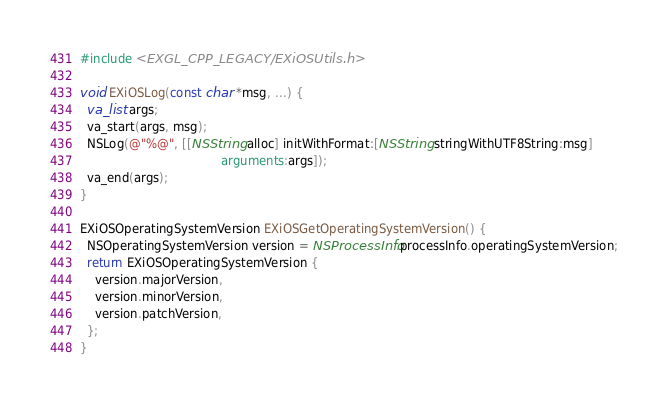Convert code to text. <code><loc_0><loc_0><loc_500><loc_500><_ObjectiveC_>#include <EXGL_CPP_LEGACY/EXiOSUtils.h>

void EXiOSLog(const char *msg, ...) {
  va_list args;
  va_start(args, msg);
  NSLog(@"%@", [[NSString alloc] initWithFormat:[NSString stringWithUTF8String:msg]
                                      arguments:args]);
  va_end(args);
}

EXiOSOperatingSystemVersion EXiOSGetOperatingSystemVersion() {
  NSOperatingSystemVersion version = NSProcessInfo.processInfo.operatingSystemVersion;
  return EXiOSOperatingSystemVersion {
    version.majorVersion,
    version.minorVersion,
    version.patchVersion,
  };
}
</code> 